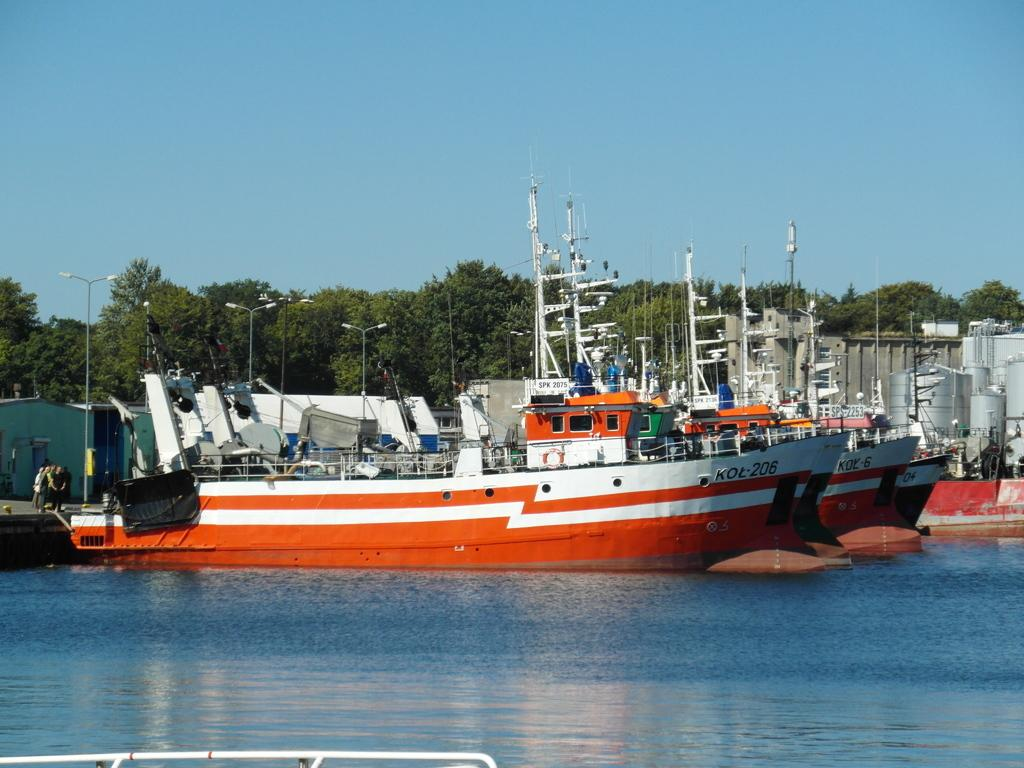What can be seen on the water in the image? There are boats on the water in the image. What is happening in the background of the image? There are persons standing, a shed, lights attached to poles, tanks, a building, and trees visible in the background. What is the color of the sky in the image? The sky is blue in the image. What type of books can be seen on the plate in the image? There are no books or plates present in the image. What material is the silk used for in the image? There is no silk present in the image. 